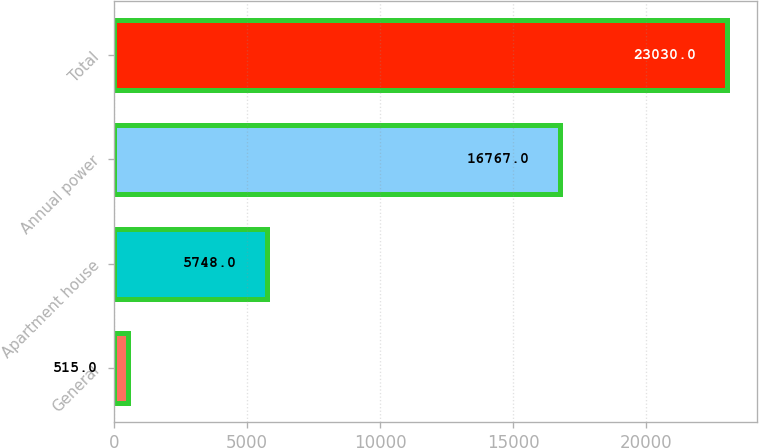Convert chart. <chart><loc_0><loc_0><loc_500><loc_500><bar_chart><fcel>General<fcel>Apartment house<fcel>Annual power<fcel>Total<nl><fcel>515<fcel>5748<fcel>16767<fcel>23030<nl></chart> 